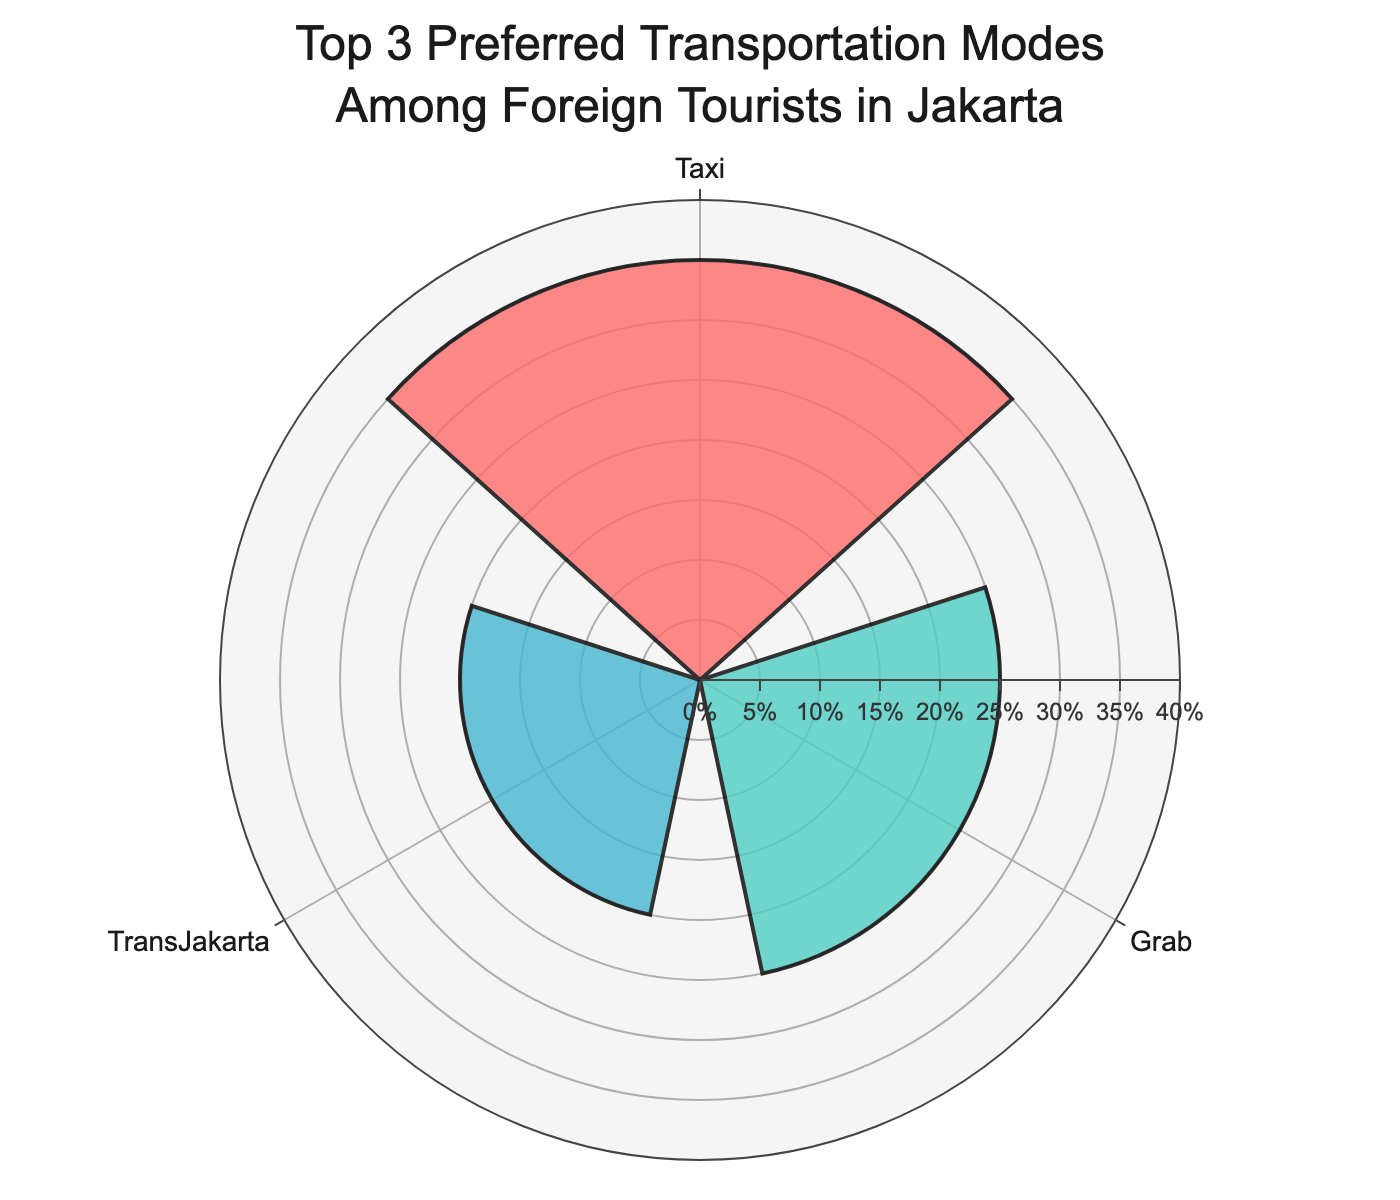1. What is the title of the chart? The chart title is prominently displayed at the top, reading "Top 3 Preferred Transportation Modes Among Foreign Tourists in Jakarta".
Answer: Top 3 Preferred Transportation Modes Among Foreign Tourists in Jakarta 2. Which transportation mode is preferred by the highest percentage of foreign tourists in Jakarta? The chart shows the highest bar in the rose chart for "Taxi", indicating that it is the preferred transportation mode for the largest percentage of tourists.
Answer: Taxi 3. How many transportation modes are displayed in the chart? There are three distinct sectors in the rose chart, each representing a different mode of transport.
Answer: 3 4. What percentage of foreign tourists prefer Grab? Referring to the "Grab" section of the rose chart, it shows that 25% of foreign tourists prefer Grab.
Answer: 25% 5. How does the popularity of MRT compare to TransJakarta? Both "MRT" and "TransJakarta" have equal segments in the rose chart, indicating that the percentage of foreign tourists that prefer these transportation modes is the same.
Answer: They are equal 6. What is the combined percentage of foreign tourists who prefer TransJakarta and MRT? The chart shows 20% for both TransJakarta and MRT. Adding these values gives 20% + 20% = 40%.
Answer: 40% 7. What is the color used for the segment representing Taxi? The segment representing "Taxi" is colored in a distinctive shade of red.
Answer: Red 8. If 100 foreign tourists were surveyed, how many of them would prefer Taxi? With Taxi preferred by 35% of tourists, this translates to 35 out of 100 tourists.
Answer: 35 9. Compare the popularity of the top two transportation modes. By comparing the percentages, Taxi (35%) is more popular than Grab (25%) by a margin of 35% - 25% = 10%.
Answer: Taxi is 10% more popular than Grab 